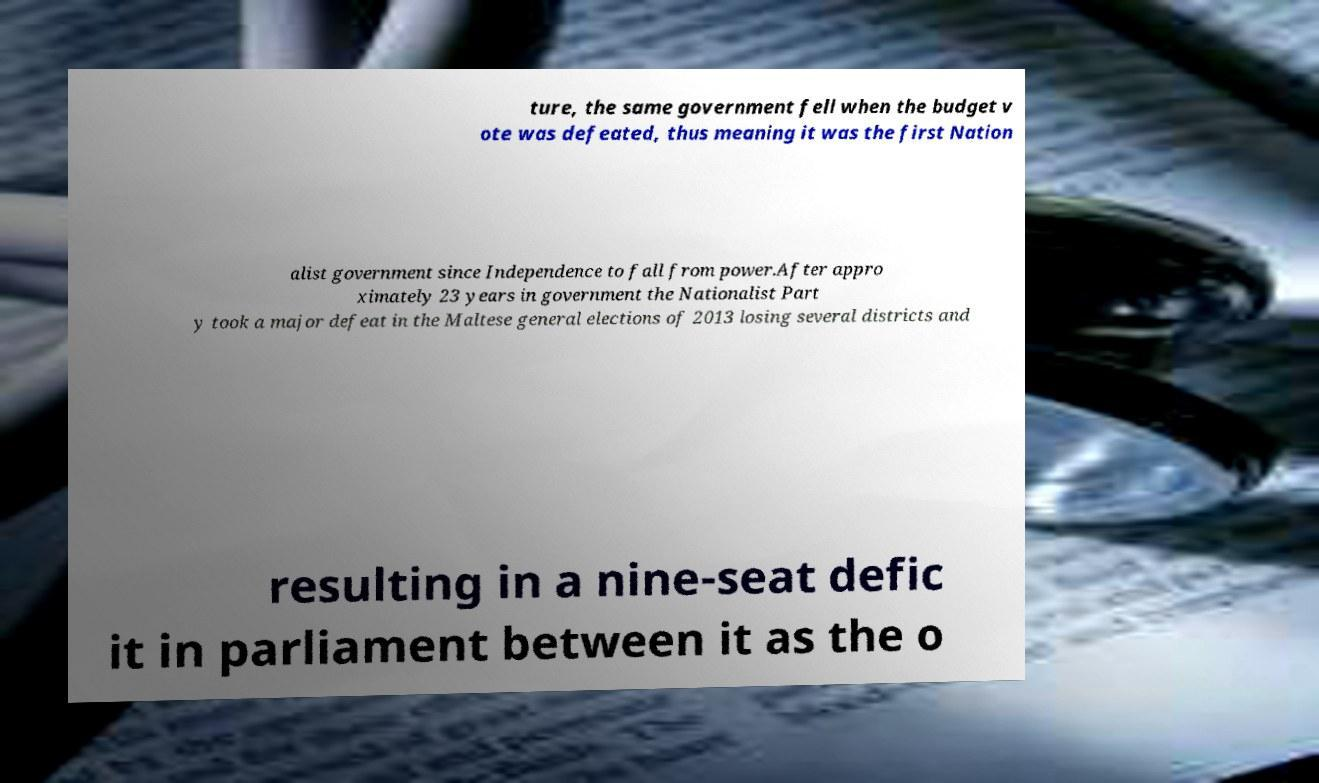Please read and relay the text visible in this image. What does it say? ture, the same government fell when the budget v ote was defeated, thus meaning it was the first Nation alist government since Independence to fall from power.After appro ximately 23 years in government the Nationalist Part y took a major defeat in the Maltese general elections of 2013 losing several districts and resulting in a nine-seat defic it in parliament between it as the o 